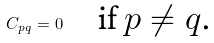Convert formula to latex. <formula><loc_0><loc_0><loc_500><loc_500>C _ { p q } = 0 \quad \text {if $p\ne q$.}</formula> 